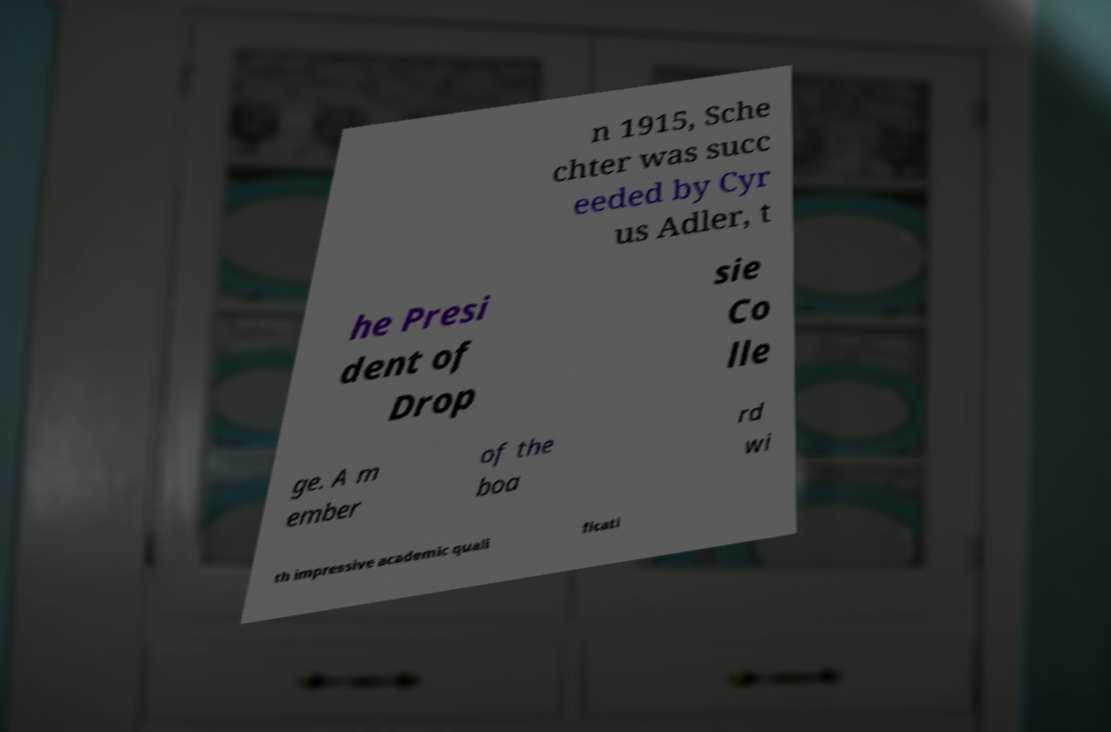Please identify and transcribe the text found in this image. n 1915, Sche chter was succ eeded by Cyr us Adler, t he Presi dent of Drop sie Co lle ge. A m ember of the boa rd wi th impressive academic quali ficati 